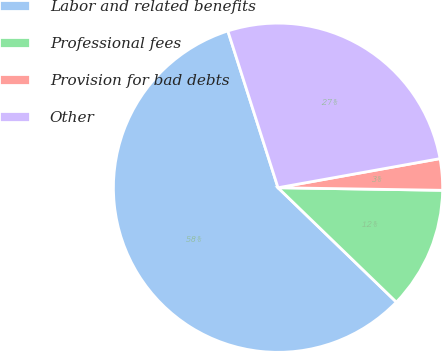Convert chart to OTSL. <chart><loc_0><loc_0><loc_500><loc_500><pie_chart><fcel>Labor and related benefits<fcel>Professional fees<fcel>Provision for bad debts<fcel>Other<nl><fcel>57.84%<fcel>11.98%<fcel>3.08%<fcel>27.1%<nl></chart> 